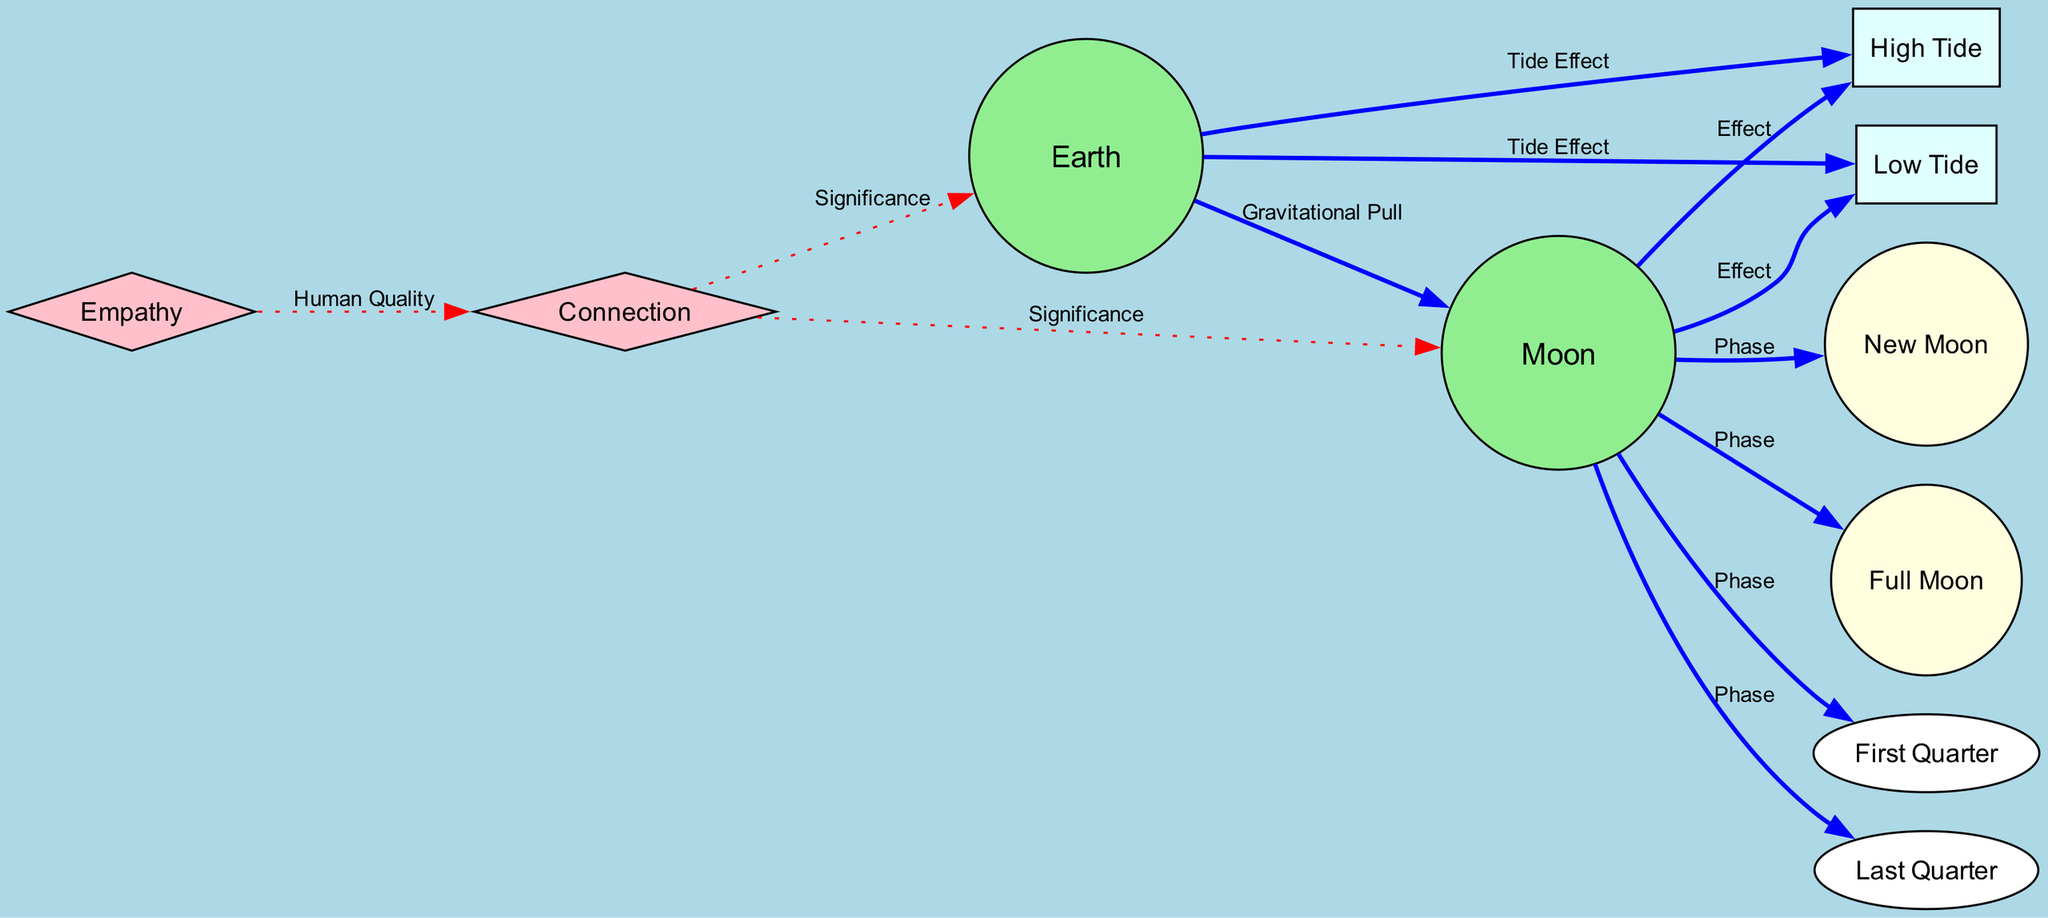What is the relationship between Earth and the Moon? The diagram indicates a mutual attraction described as gravitational pull between Earth and the Moon, implying a close physical and emotional connection.
Answer: Gravitational Pull What are the phases of the Moon represented in the diagram? The diagram depicts four phases of the Moon: New Moon, Full Moon, First Quarter, and Last Quarter, showcasing the different stages of illumination.
Answer: New Moon, Full Moon, First Quarter, Last Quarter How many edges connect the Moon to its phases? The diagram shows that the Moon is connected to four phases via edges, specifically to New Moon, Full Moon, First Quarter, and Last Quarter, indicating different relationships with each phase.
Answer: 4 What effect does the Moon have on the tides? The diagram specifies that the Moon affects tides through high tide and low tide, creating a connection that impacts ocean levels based on its gravitational influence.
Answer: High Tide, Low Tide How does empathy relate to the connection between Earth and the Moon? The diagram indicates that empathy is a human quality that enables emotional understanding, which strengthens the bond between Earth and Moon as depicted via multiple edges emanating from empathy and connection nodes.
Answer: Emotional Understanding What is the illumination percentage during a Full Moon? The diagram presents that during a Full Moon, the level of illumination is 100%, defining the highest visibility of the Moon in its cycle.
Answer: 100% What does the high tide represent in relation to Earth? In the diagram, high tide represents the point where ocean levels rise due to the strong gravitational pull exerted by the Moon on the Earth, highlighting their intertwined relationship.
Answer: Ocean levels rise What are the emotional qualities depicted alongside the connection between Earth and Moon? The diagram links empathy and connection to suggest that understanding others' emotions and bonds can be related to the gravitational relationship between Earth and Moon, reflecting on how natural phenomena can inspire emotional connections in humans.
Answer: Empathy, Connection How are the phases of the Moon linked to its position relative to the Sun and Earth? The diagram illustrates that each phase of the Moon corresponds to its specific position in relation to Earth and the Sun, such as the New Moon being between Earth and the Sun and the Full Moon being when Earth is between the Moon and the Sun, thereby affecting visibility and tide.
Answer: Phase Positioning 